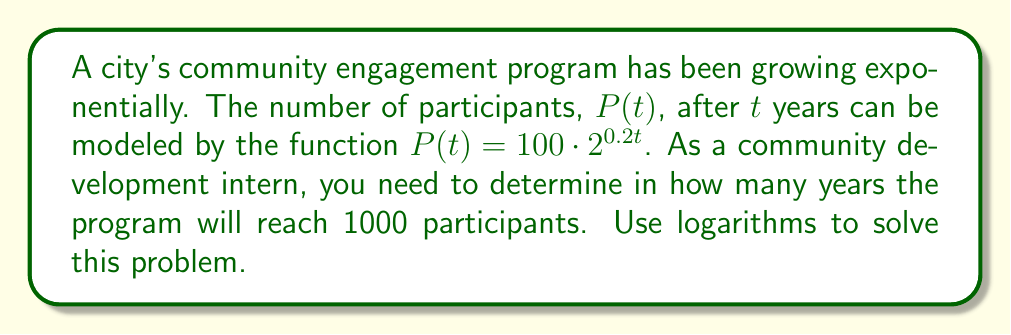What is the answer to this math problem? 1) We start with the equation:
   $P(t) = 100 \cdot 2^{0.2t}$

2) We want to find $t$ when $P(t) = 1000$, so we set up the equation:
   $1000 = 100 \cdot 2^{0.2t}$

3) Divide both sides by 100:
   $10 = 2^{0.2t}$

4) Take the logarithm (base 2) of both sides:
   $\log_2(10) = \log_2(2^{0.2t})$

5) Using the logarithm property $\log_a(a^x) = x$, we get:
   $\log_2(10) = 0.2t$

6) Solve for $t$:
   $t = \frac{\log_2(10)}{0.2}$

7) We can change the base of the logarithm using the change of base formula:
   $t = \frac{\ln(10)}{\ln(2) \cdot 0.2}$

8) Calculate the result:
   $t \approx 16.61$ years

9) Since we're dealing with whole years, we round up to the next integer:
   $t = 17$ years
Answer: 17 years 